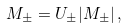<formula> <loc_0><loc_0><loc_500><loc_500>M _ { \pm } = U _ { \pm } | M _ { \pm } | \, ,</formula> 